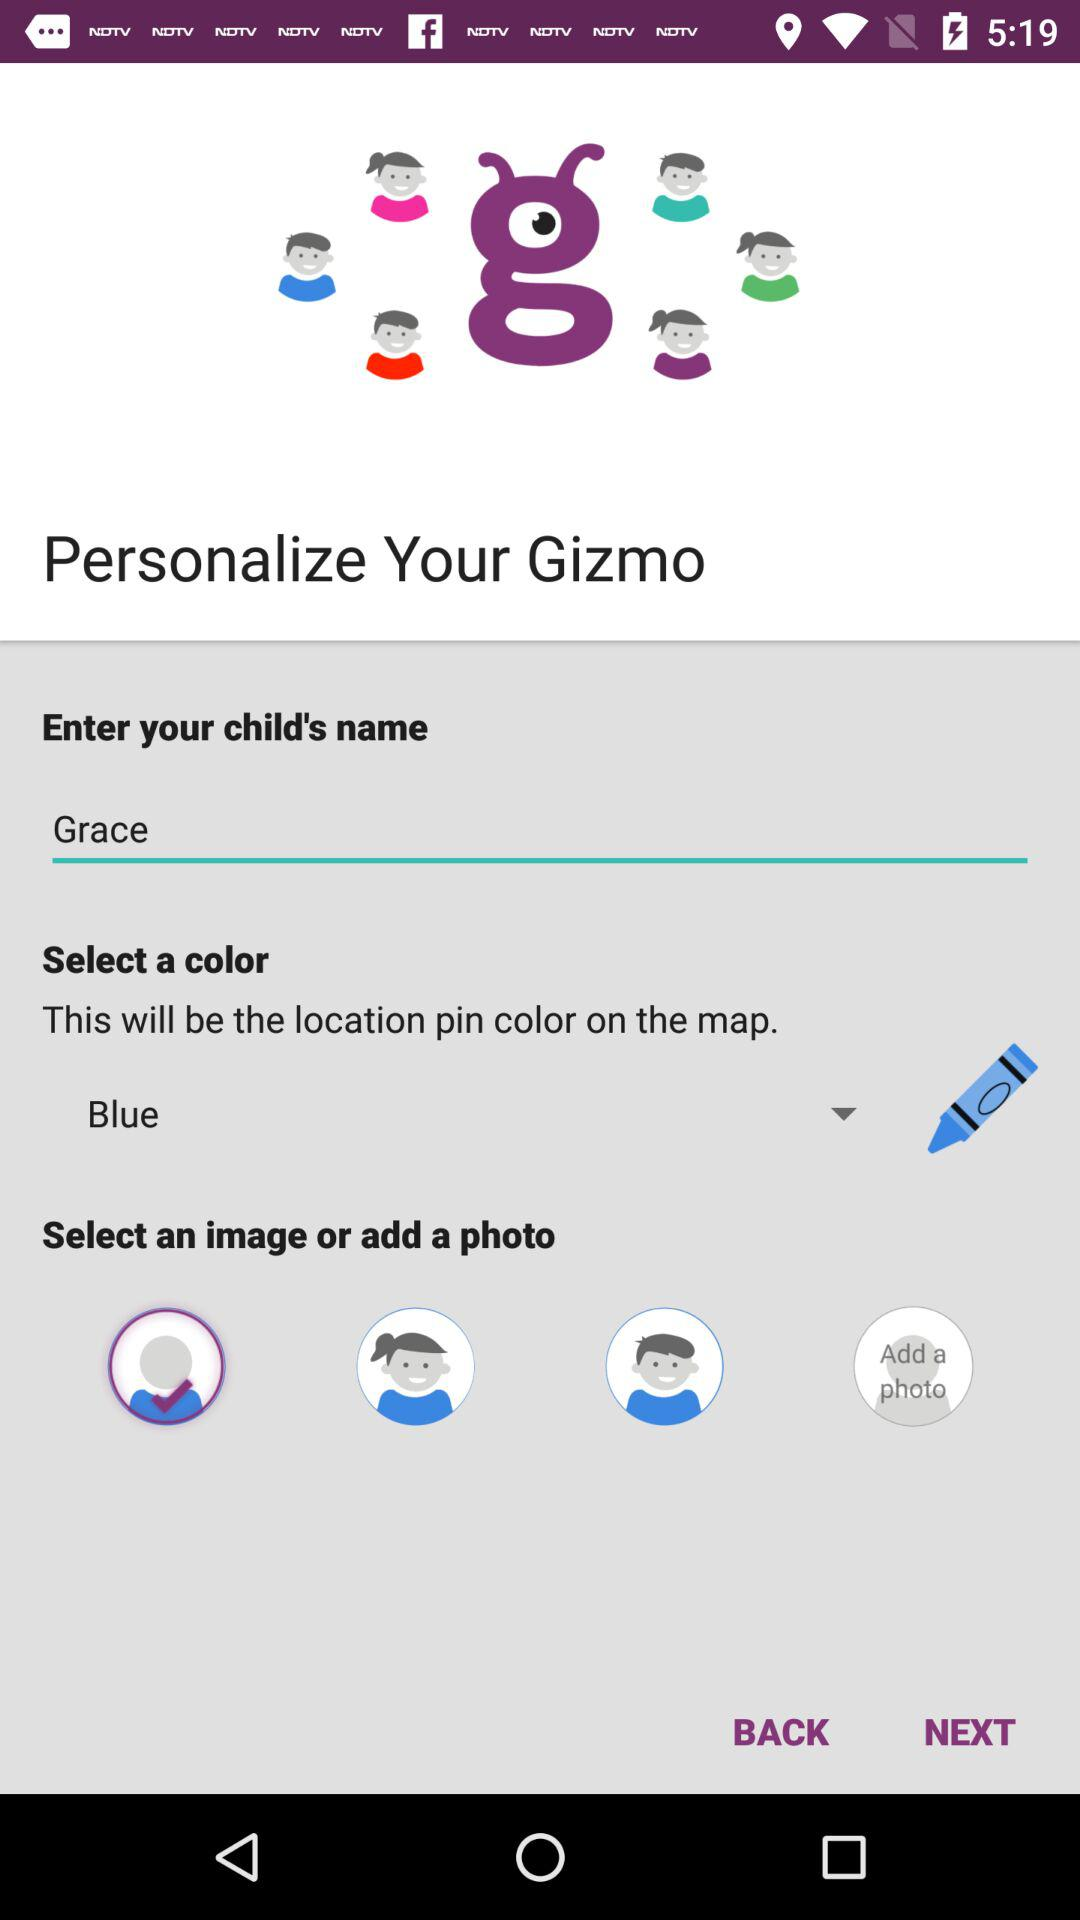What is the child's name? The child's name is Grace. 